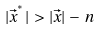Convert formula to latex. <formula><loc_0><loc_0><loc_500><loc_500>| \vec { x } ^ { ^ { * } } | \, > \, | \vec { x } | \, - \, n</formula> 